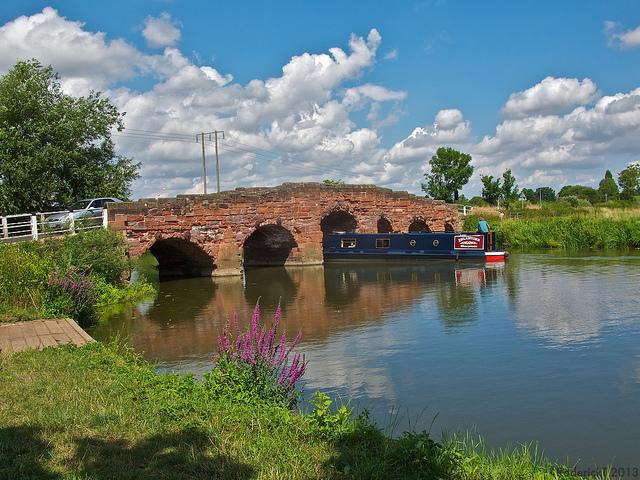Where is the boat going? under bridge 